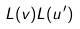Convert formula to latex. <formula><loc_0><loc_0><loc_500><loc_500>L ( v ) L ( u ^ { \prime } )</formula> 